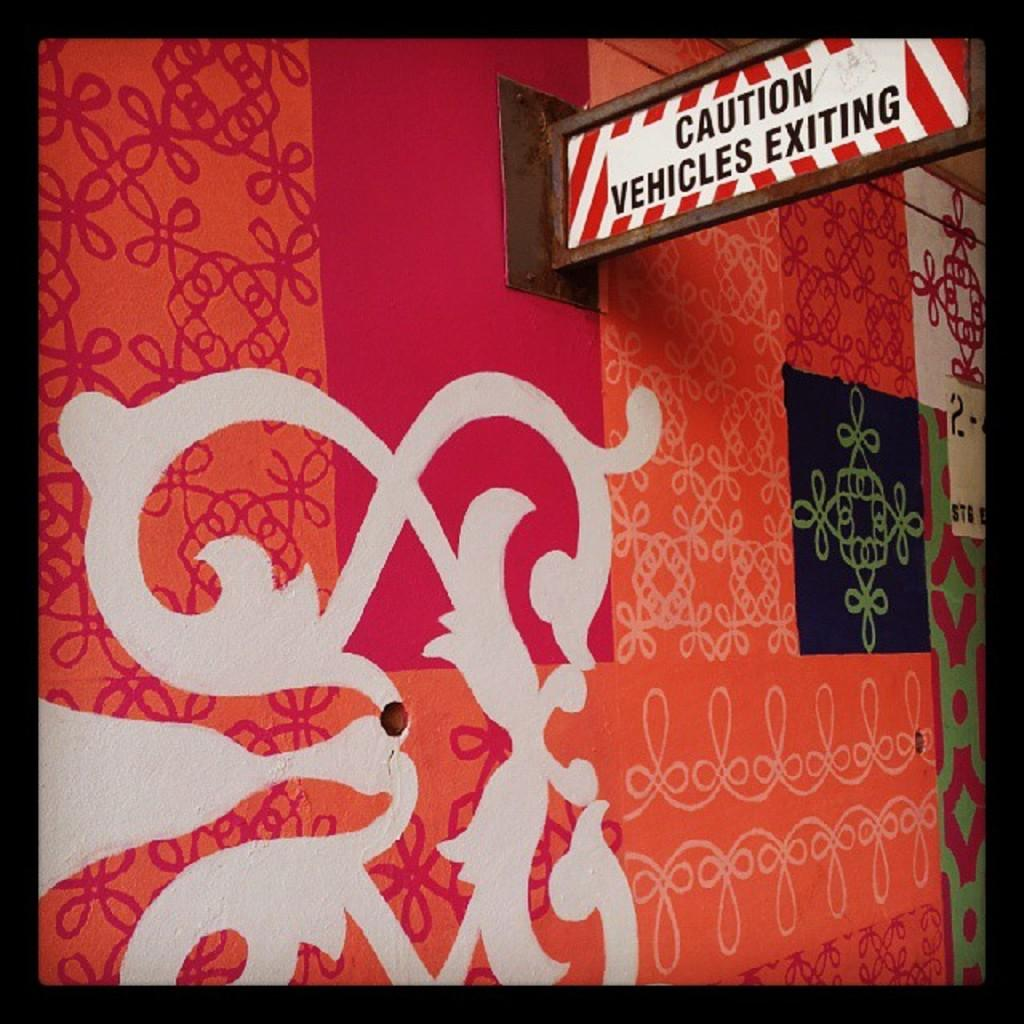<image>
Render a clear and concise summary of the photo. A colorful wall with many designs including a sign that reads: Caution Vehicles Exiting. 